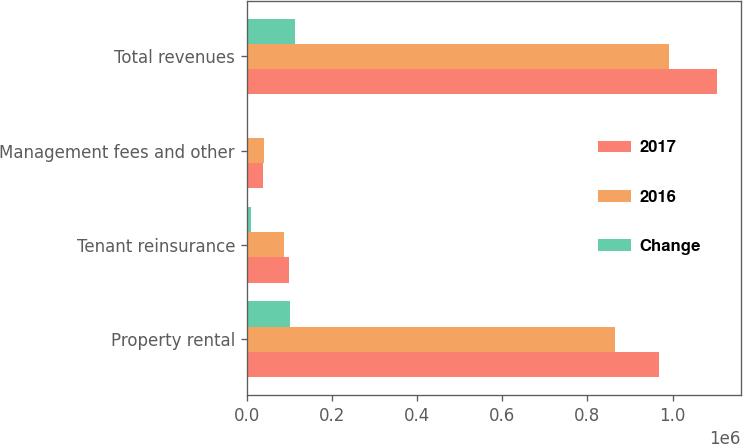<chart> <loc_0><loc_0><loc_500><loc_500><stacked_bar_chart><ecel><fcel>Property rental<fcel>Tenant reinsurance<fcel>Management fees and other<fcel>Total revenues<nl><fcel>2017<fcel>967229<fcel>98401<fcel>39379<fcel>1.10501e+06<nl><fcel>2016<fcel>864742<fcel>87291<fcel>39842<fcel>991875<nl><fcel>Change<fcel>102487<fcel>11110<fcel>463<fcel>113134<nl></chart> 